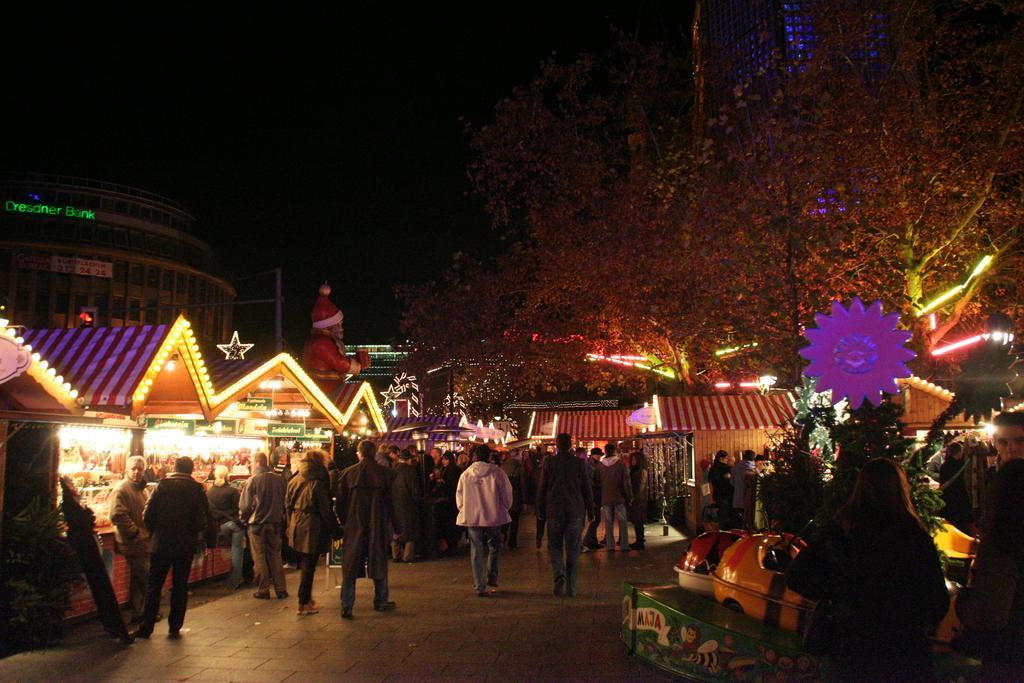How would you summarize this image in a sentence or two? In this image I can see at the bottom few people are walking on the left side there are stores with the lights. At the back side there is a doll in the shape of a Christmas grand father. On the right side few people are sitting on the toys and there are trees in this image. 